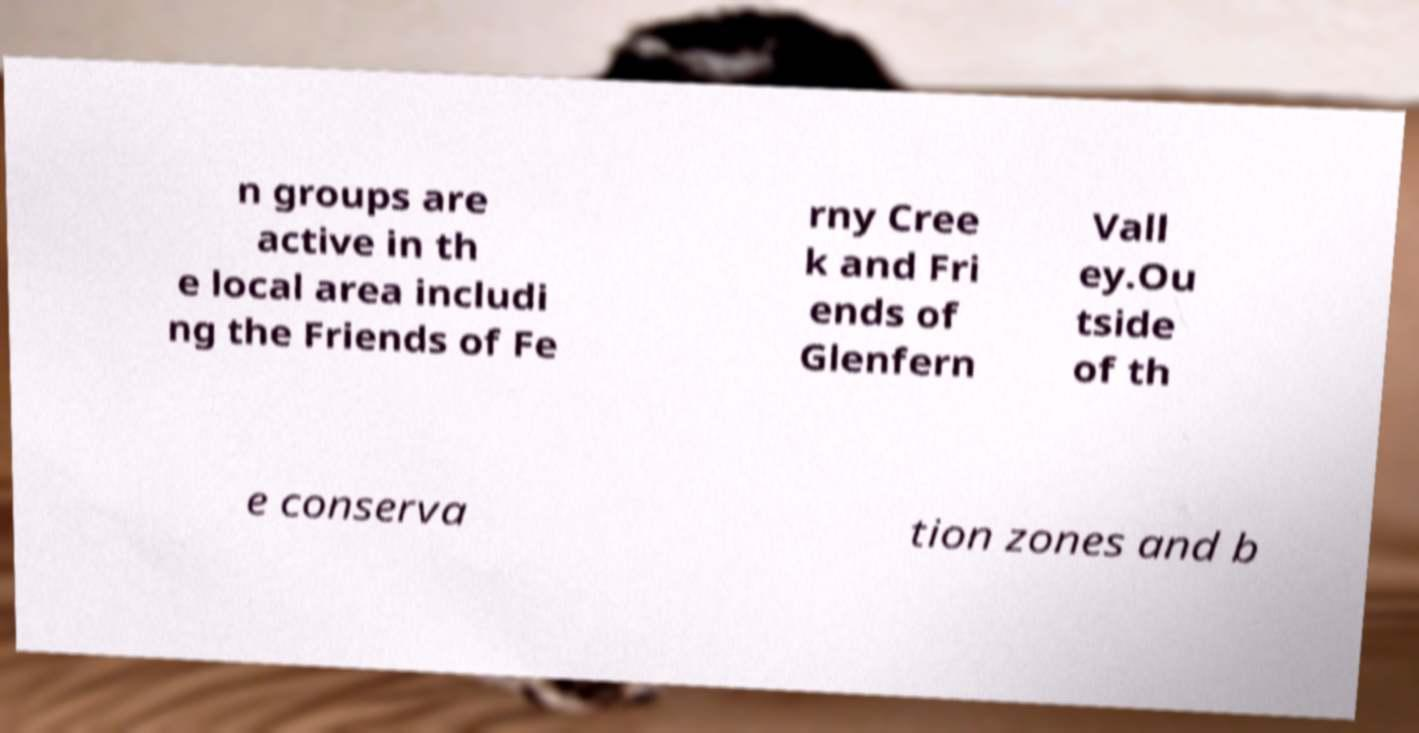Can you read and provide the text displayed in the image?This photo seems to have some interesting text. Can you extract and type it out for me? n groups are active in th e local area includi ng the Friends of Fe rny Cree k and Fri ends of Glenfern Vall ey.Ou tside of th e conserva tion zones and b 